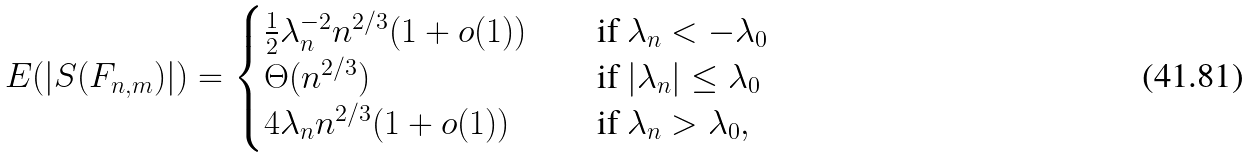Convert formula to latex. <formula><loc_0><loc_0><loc_500><loc_500>E ( | S ( F _ { n , m } ) | ) = \begin{cases} \frac { 1 } { 2 } \lambda _ { n } ^ { - 2 } { n ^ { 2 / 3 } } ( 1 + o ( 1 ) ) & \quad \text {if $ \lambda_{n} < -\lambda_{0}$} \\ \Theta ( n ^ { 2 / 3 } ) & \quad \text {if $ |\lambda_{n}| \leq \lambda_{0}$} \\ 4 \lambda _ { n } n ^ { 2 / 3 } ( 1 + o ( 1 ) ) & \quad \text {if $ \lambda_{n} > \lambda_{0}$} , \end{cases}</formula> 